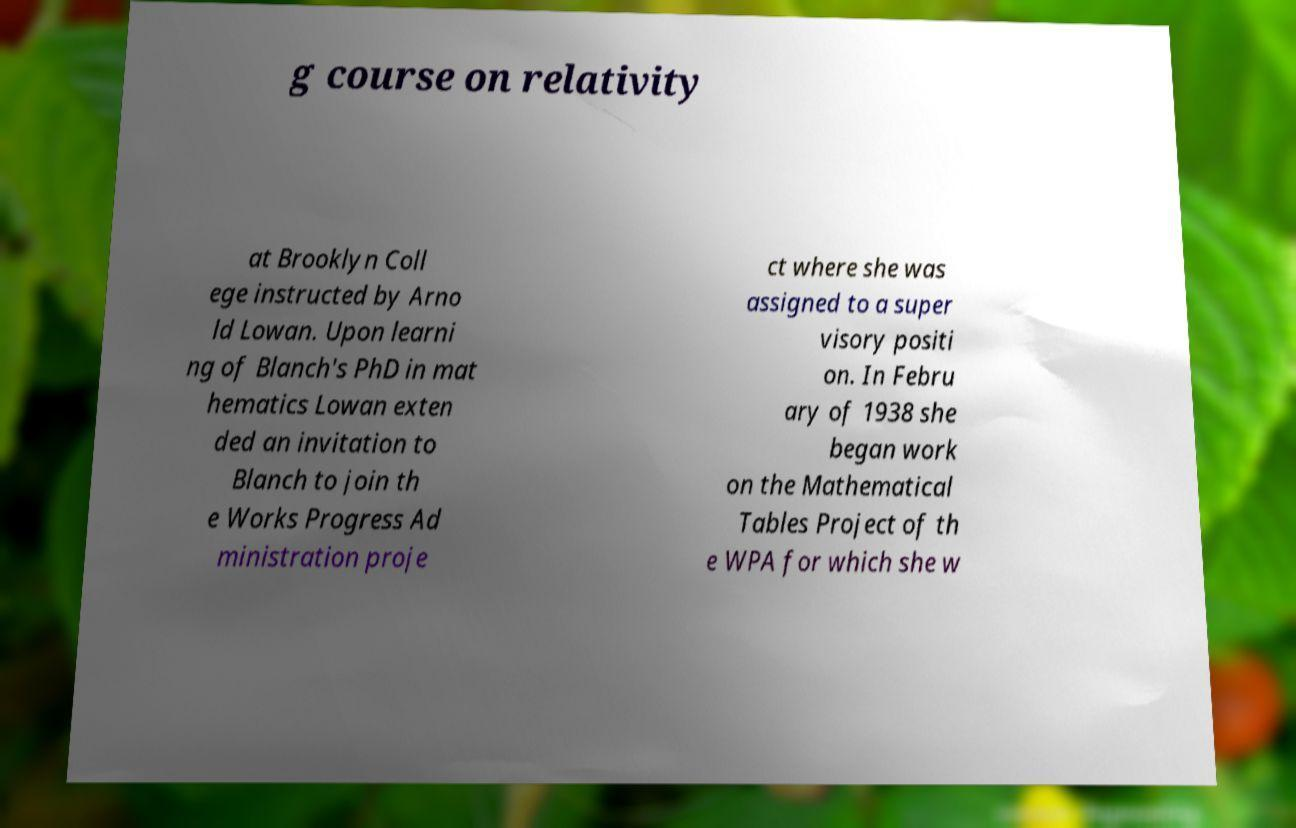Could you assist in decoding the text presented in this image and type it out clearly? g course on relativity at Brooklyn Coll ege instructed by Arno ld Lowan. Upon learni ng of Blanch's PhD in mat hematics Lowan exten ded an invitation to Blanch to join th e Works Progress Ad ministration proje ct where she was assigned to a super visory positi on. In Febru ary of 1938 she began work on the Mathematical Tables Project of th e WPA for which she w 